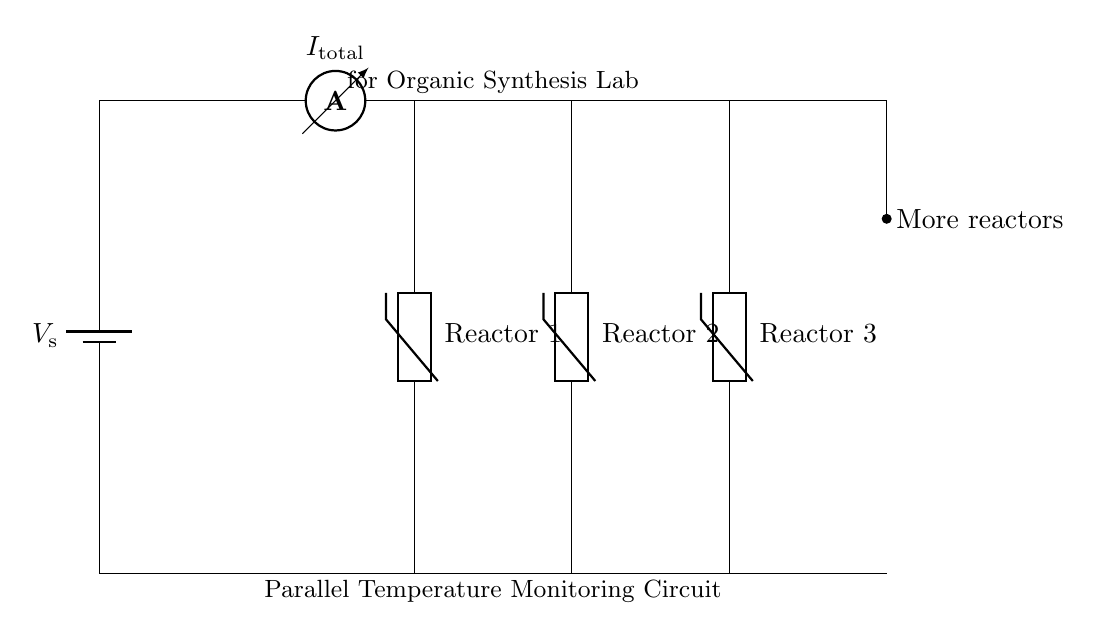What is the type of this circuit? The circuit is a parallel circuit, as indicated by the multiple branches for each thermistor connected across the same voltage supply, creating separate paths for current to flow.
Answer: Parallel How many reactors are monitored in this circuit? Three thermistors, labeled as Reactor 1, Reactor 2, and Reactor 3, are clearly shown in the diagram, each representing an independent temperature measurement.
Answer: Three What component measures the total current in the circuit? The ammeter, placed in series at the beginning of the circuit, is used to measure the total current flowing through the circuit as it passes through all branches.
Answer: Ammeter What is the role of the thermistors in this circuit? Each thermistor functions as a temperature sensor, allowing for real-time monitoring of the temperature in their respective reaction vessels by providing resistance changes with temperature fluctuations.
Answer: Temperature sensors What does the notation "More reactors" signify in the circuit? This notation indicates that additional reactors can be connected in parallel to the existing setup, highlighting the scalability of the circuit for monitoring multiple temperatures simultaneously.
Answer: Scalability What is the significance of the battery in this circuit? The battery provides the necessary voltage source (indicated as V_s) to power the circuit and ensure that each thermistor can function correctly to measure temperature.
Answer: Voltage source 